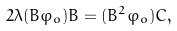<formula> <loc_0><loc_0><loc_500><loc_500>2 \lambda ( B \varphi _ { o } ) B = ( B ^ { 2 } \varphi _ { o } ) C ,</formula> 